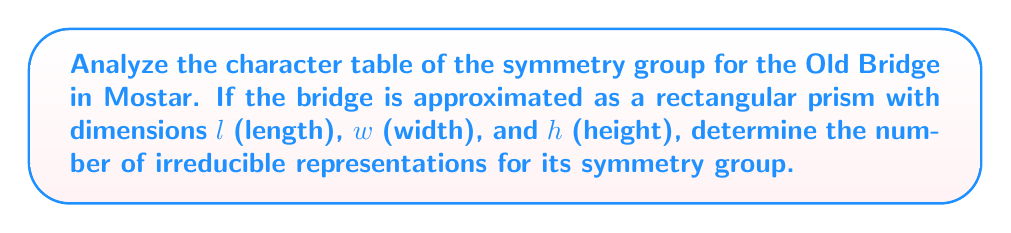What is the answer to this math problem? Let's approach this step-by-step:

1) The Old Bridge in Mostar can be approximated as a rectangular prism. The symmetry group of a rectangular prism is $D_{2h}$, which is isomorphic to $C_{2v} \times C_2$.

2) The order of $D_{2h}$ is 8. Its elements are:
   - $E$ (identity)
   - $C_2(x)$, $C_2(y)$, $C_2(z)$ (180° rotations around x, y, and z axes)
   - $i$ (inversion)
   - $\sigma(xy)$, $\sigma(xz)$, $\sigma(yz)$ (reflections in xy, xz, and yz planes)

3) To determine the number of irreducible representations, we can use the following theorem:
   The number of irreducible representations is equal to the number of conjugacy classes.

4) For $D_{2h}$, each element forms its own conjugacy class. This is because $D_{2h}$ is an abelian group, and in abelian groups, each element is in a conjugacy class by itself.

5) Therefore, the number of conjugacy classes is equal to the number of elements, which is 8.

Thus, the symmetry group of the Old Bridge (approximated as a rectangular prism) has 8 irreducible representations.
Answer: 8 